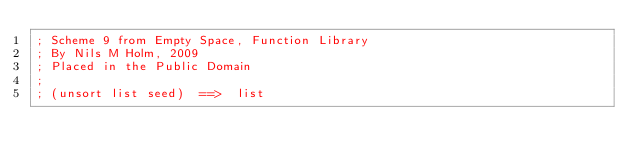<code> <loc_0><loc_0><loc_500><loc_500><_Scheme_>; Scheme 9 from Empty Space, Function Library
; By Nils M Holm, 2009
; Placed in the Public Domain
;
; (unsort list seed)  ==>  list</code> 